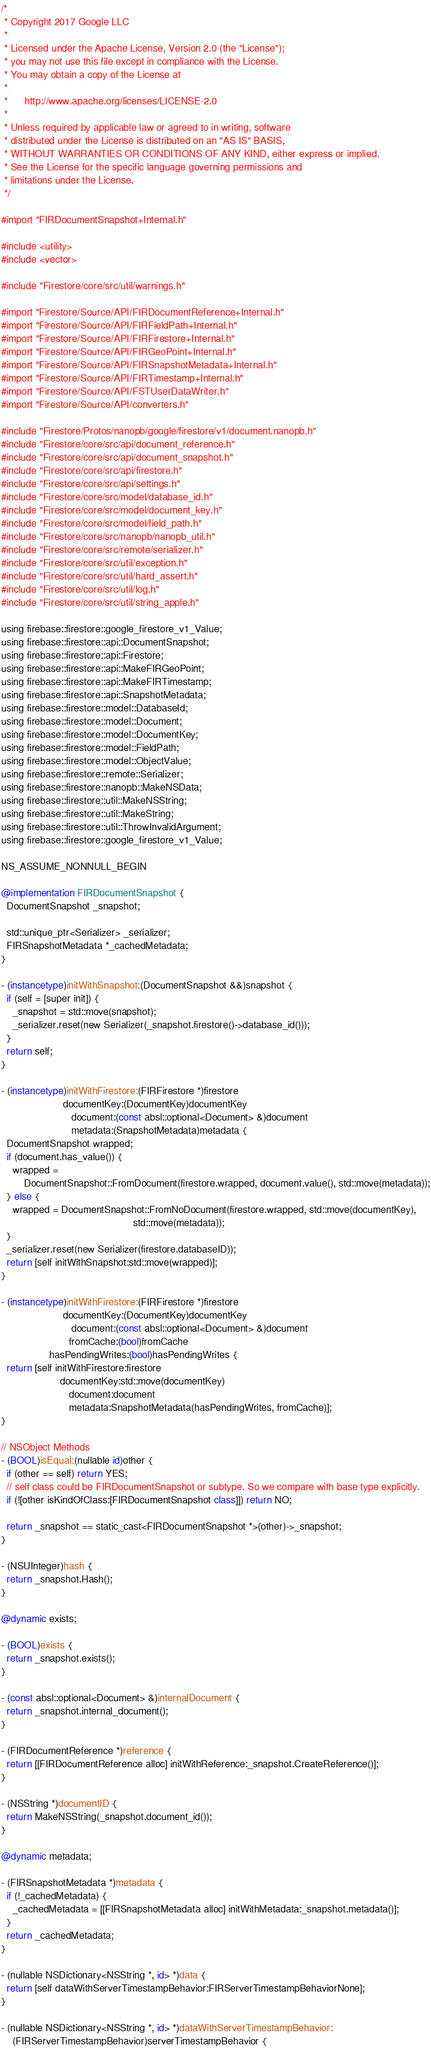<code> <loc_0><loc_0><loc_500><loc_500><_ObjectiveC_>/*
 * Copyright 2017 Google LLC
 *
 * Licensed under the Apache License, Version 2.0 (the "License");
 * you may not use this file except in compliance with the License.
 * You may obtain a copy of the License at
 *
 *      http://www.apache.org/licenses/LICENSE-2.0
 *
 * Unless required by applicable law or agreed to in writing, software
 * distributed under the License is distributed on an "AS IS" BASIS,
 * WITHOUT WARRANTIES OR CONDITIONS OF ANY KIND, either express or implied.
 * See the License for the specific language governing permissions and
 * limitations under the License.
 */

#import "FIRDocumentSnapshot+Internal.h"

#include <utility>
#include <vector>

#include "Firestore/core/src/util/warnings.h"

#import "Firestore/Source/API/FIRDocumentReference+Internal.h"
#import "Firestore/Source/API/FIRFieldPath+Internal.h"
#import "Firestore/Source/API/FIRFirestore+Internal.h"
#import "Firestore/Source/API/FIRGeoPoint+Internal.h"
#import "Firestore/Source/API/FIRSnapshotMetadata+Internal.h"
#import "Firestore/Source/API/FIRTimestamp+Internal.h"
#import "Firestore/Source/API/FSTUserDataWriter.h"
#import "Firestore/Source/API/converters.h"

#include "Firestore/Protos/nanopb/google/firestore/v1/document.nanopb.h"
#include "Firestore/core/src/api/document_reference.h"
#include "Firestore/core/src/api/document_snapshot.h"
#include "Firestore/core/src/api/firestore.h"
#include "Firestore/core/src/api/settings.h"
#include "Firestore/core/src/model/database_id.h"
#include "Firestore/core/src/model/document_key.h"
#include "Firestore/core/src/model/field_path.h"
#include "Firestore/core/src/nanopb/nanopb_util.h"
#include "Firestore/core/src/remote/serializer.h"
#include "Firestore/core/src/util/exception.h"
#include "Firestore/core/src/util/hard_assert.h"
#include "Firestore/core/src/util/log.h"
#include "Firestore/core/src/util/string_apple.h"

using firebase::firestore::google_firestore_v1_Value;
using firebase::firestore::api::DocumentSnapshot;
using firebase::firestore::api::Firestore;
using firebase::firestore::api::MakeFIRGeoPoint;
using firebase::firestore::api::MakeFIRTimestamp;
using firebase::firestore::api::SnapshotMetadata;
using firebase::firestore::model::DatabaseId;
using firebase::firestore::model::Document;
using firebase::firestore::model::DocumentKey;
using firebase::firestore::model::FieldPath;
using firebase::firestore::model::ObjectValue;
using firebase::firestore::remote::Serializer;
using firebase::firestore::nanopb::MakeNSData;
using firebase::firestore::util::MakeNSString;
using firebase::firestore::util::MakeString;
using firebase::firestore::util::ThrowInvalidArgument;
using firebase::firestore::google_firestore_v1_Value;

NS_ASSUME_NONNULL_BEGIN

@implementation FIRDocumentSnapshot {
  DocumentSnapshot _snapshot;

  std::unique_ptr<Serializer> _serializer;
  FIRSnapshotMetadata *_cachedMetadata;
}

- (instancetype)initWithSnapshot:(DocumentSnapshot &&)snapshot {
  if (self = [super init]) {
    _snapshot = std::move(snapshot);
    _serializer.reset(new Serializer(_snapshot.firestore()->database_id()));
  }
  return self;
}

- (instancetype)initWithFirestore:(FIRFirestore *)firestore
                      documentKey:(DocumentKey)documentKey
                         document:(const absl::optional<Document> &)document
                         metadata:(SnapshotMetadata)metadata {
  DocumentSnapshot wrapped;
  if (document.has_value()) {
    wrapped =
        DocumentSnapshot::FromDocument(firestore.wrapped, document.value(), std::move(metadata));
  } else {
    wrapped = DocumentSnapshot::FromNoDocument(firestore.wrapped, std::move(documentKey),
                                               std::move(metadata));
  }
  _serializer.reset(new Serializer(firestore.databaseID));
  return [self initWithSnapshot:std::move(wrapped)];
}

- (instancetype)initWithFirestore:(FIRFirestore *)firestore
                      documentKey:(DocumentKey)documentKey
                         document:(const absl::optional<Document> &)document
                        fromCache:(bool)fromCache
                 hasPendingWrites:(bool)hasPendingWrites {
  return [self initWithFirestore:firestore
                     documentKey:std::move(documentKey)
                        document:document
                        metadata:SnapshotMetadata(hasPendingWrites, fromCache)];
}

// NSObject Methods
- (BOOL)isEqual:(nullable id)other {
  if (other == self) return YES;
  // self class could be FIRDocumentSnapshot or subtype. So we compare with base type explicitly.
  if (![other isKindOfClass:[FIRDocumentSnapshot class]]) return NO;

  return _snapshot == static_cast<FIRDocumentSnapshot *>(other)->_snapshot;
}

- (NSUInteger)hash {
  return _snapshot.Hash();
}

@dynamic exists;

- (BOOL)exists {
  return _snapshot.exists();
}

- (const absl::optional<Document> &)internalDocument {
  return _snapshot.internal_document();
}

- (FIRDocumentReference *)reference {
  return [[FIRDocumentReference alloc] initWithReference:_snapshot.CreateReference()];
}

- (NSString *)documentID {
  return MakeNSString(_snapshot.document_id());
}

@dynamic metadata;

- (FIRSnapshotMetadata *)metadata {
  if (!_cachedMetadata) {
    _cachedMetadata = [[FIRSnapshotMetadata alloc] initWithMetadata:_snapshot.metadata()];
  }
  return _cachedMetadata;
}

- (nullable NSDictionary<NSString *, id> *)data {
  return [self dataWithServerTimestampBehavior:FIRServerTimestampBehaviorNone];
}

- (nullable NSDictionary<NSString *, id> *)dataWithServerTimestampBehavior:
    (FIRServerTimestampBehavior)serverTimestampBehavior {</code> 